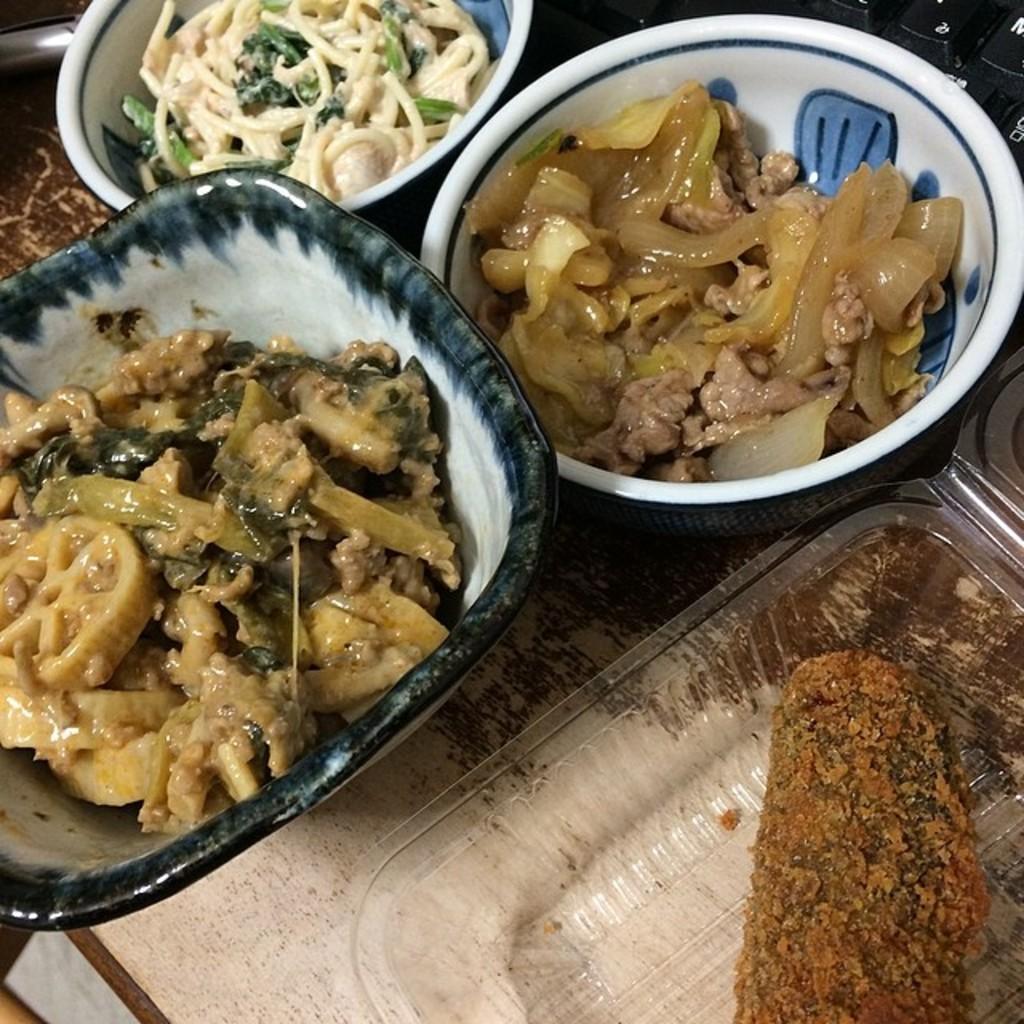Could you give a brief overview of what you see in this image? In this image, we can see some food in the containers. 